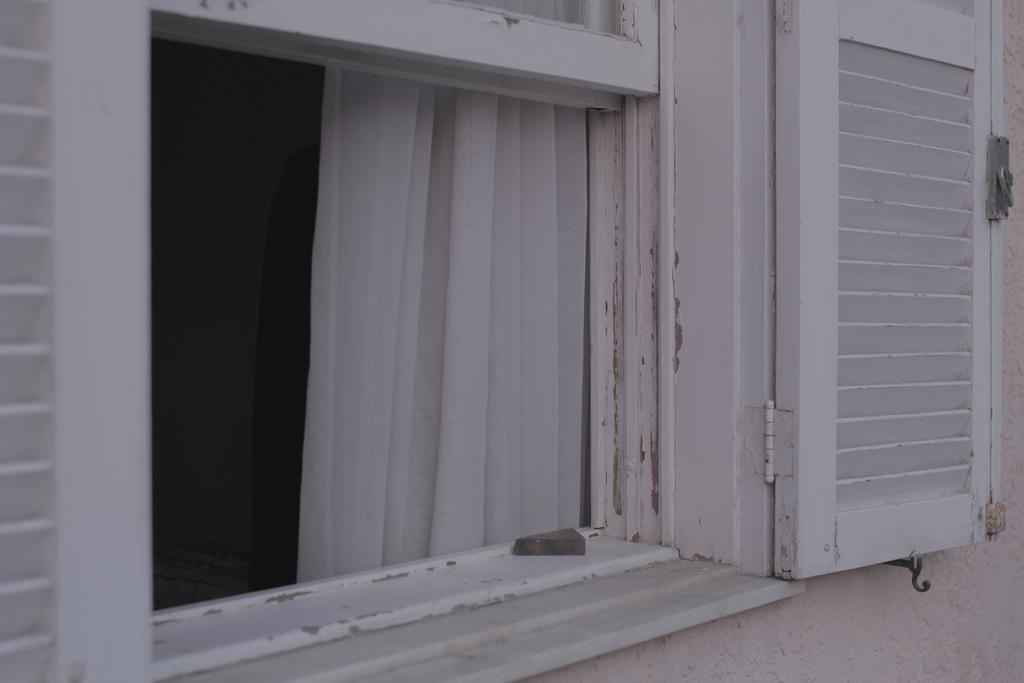Can you describe this image briefly? In this image, there is a window with a door. I can see a curtain hanging through the window. At the bottom of the image, I can see the wall. 